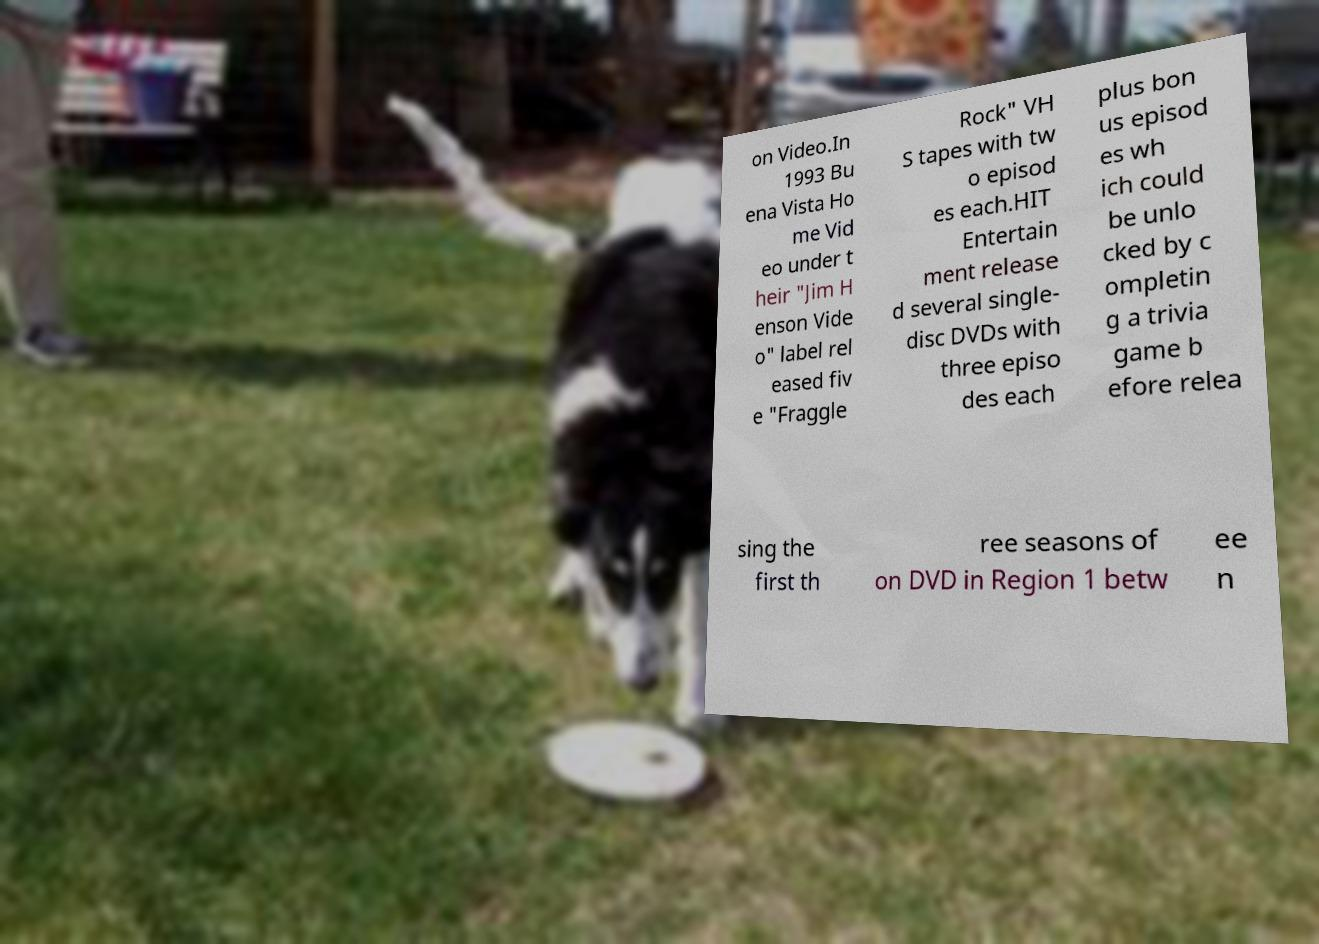For documentation purposes, I need the text within this image transcribed. Could you provide that? on Video.In 1993 Bu ena Vista Ho me Vid eo under t heir "Jim H enson Vide o" label rel eased fiv e "Fraggle Rock" VH S tapes with tw o episod es each.HIT Entertain ment release d several single- disc DVDs with three episo des each plus bon us episod es wh ich could be unlo cked by c ompletin g a trivia game b efore relea sing the first th ree seasons of on DVD in Region 1 betw ee n 